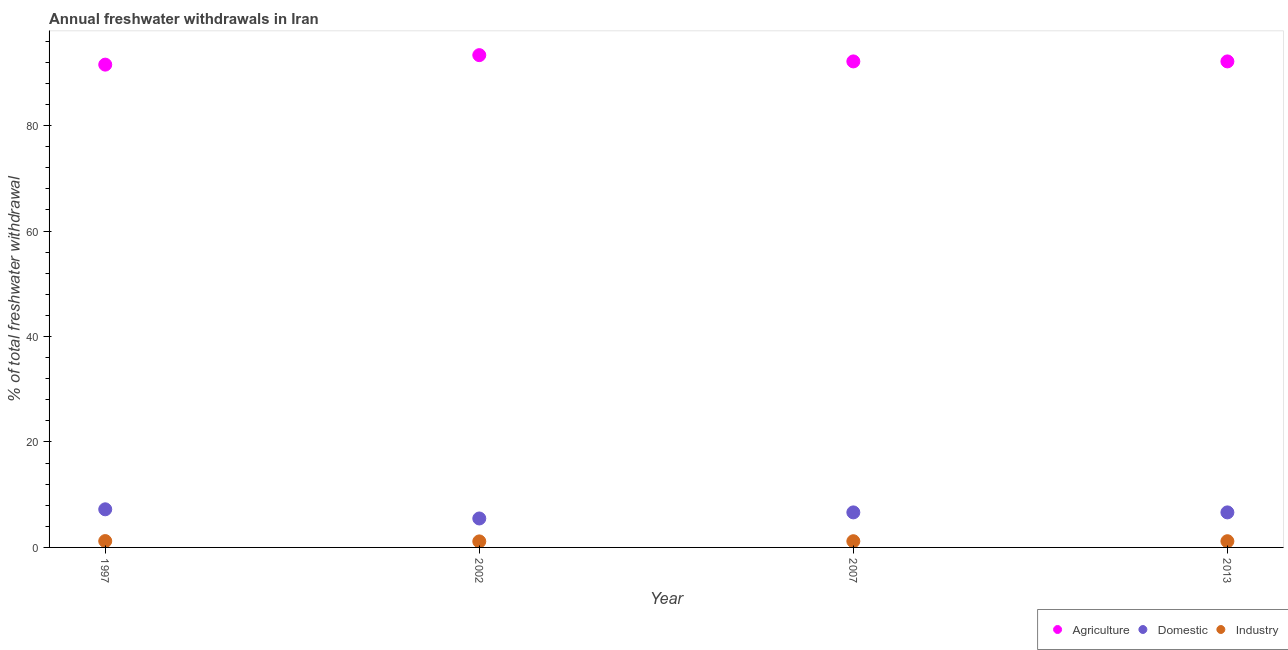Is the number of dotlines equal to the number of legend labels?
Offer a very short reply. Yes. What is the percentage of freshwater withdrawal for agriculture in 2013?
Your response must be concise. 92.18. Across all years, what is the maximum percentage of freshwater withdrawal for agriculture?
Provide a short and direct response. 93.37. Across all years, what is the minimum percentage of freshwater withdrawal for agriculture?
Your answer should be very brief. 91.57. What is the total percentage of freshwater withdrawal for agriculture in the graph?
Your response must be concise. 369.3. What is the difference between the percentage of freshwater withdrawal for industry in 1997 and that in 2013?
Your answer should be very brief. 0.03. What is the difference between the percentage of freshwater withdrawal for agriculture in 2013 and the percentage of freshwater withdrawal for industry in 2002?
Your answer should be very brief. 91.04. What is the average percentage of freshwater withdrawal for industry per year?
Give a very brief answer. 1.18. In the year 2013, what is the difference between the percentage of freshwater withdrawal for agriculture and percentage of freshwater withdrawal for domestic purposes?
Ensure brevity in your answer.  85.54. What is the ratio of the percentage of freshwater withdrawal for agriculture in 2002 to that in 2007?
Provide a succinct answer. 1.01. Is the percentage of freshwater withdrawal for agriculture in 2007 less than that in 2013?
Offer a very short reply. No. What is the difference between the highest and the second highest percentage of freshwater withdrawal for agriculture?
Provide a succinct answer. 1.19. What is the difference between the highest and the lowest percentage of freshwater withdrawal for domestic purposes?
Your answer should be very brief. 1.74. Does the percentage of freshwater withdrawal for agriculture monotonically increase over the years?
Your answer should be very brief. No. Is the percentage of freshwater withdrawal for domestic purposes strictly greater than the percentage of freshwater withdrawal for agriculture over the years?
Your response must be concise. No. Is the percentage of freshwater withdrawal for agriculture strictly less than the percentage of freshwater withdrawal for industry over the years?
Your answer should be compact. No. How many years are there in the graph?
Offer a very short reply. 4. Are the values on the major ticks of Y-axis written in scientific E-notation?
Offer a terse response. No. Does the graph contain any zero values?
Keep it short and to the point. No. How are the legend labels stacked?
Provide a short and direct response. Horizontal. What is the title of the graph?
Provide a succinct answer. Annual freshwater withdrawals in Iran. Does "Domestic" appear as one of the legend labels in the graph?
Offer a terse response. Yes. What is the label or title of the Y-axis?
Provide a succinct answer. % of total freshwater withdrawal. What is the % of total freshwater withdrawal in Agriculture in 1997?
Provide a short and direct response. 91.57. What is the % of total freshwater withdrawal of Domestic in 1997?
Ensure brevity in your answer.  7.23. What is the % of total freshwater withdrawal in Industry in 1997?
Keep it short and to the point. 1.21. What is the % of total freshwater withdrawal of Agriculture in 2002?
Your response must be concise. 93.37. What is the % of total freshwater withdrawal of Domestic in 2002?
Make the answer very short. 5.49. What is the % of total freshwater withdrawal in Industry in 2002?
Provide a succinct answer. 1.14. What is the % of total freshwater withdrawal in Agriculture in 2007?
Your answer should be compact. 92.18. What is the % of total freshwater withdrawal of Domestic in 2007?
Your response must be concise. 6.64. What is the % of total freshwater withdrawal of Industry in 2007?
Provide a succinct answer. 1.18. What is the % of total freshwater withdrawal in Agriculture in 2013?
Give a very brief answer. 92.18. What is the % of total freshwater withdrawal of Domestic in 2013?
Your response must be concise. 6.64. What is the % of total freshwater withdrawal of Industry in 2013?
Provide a short and direct response. 1.18. Across all years, what is the maximum % of total freshwater withdrawal in Agriculture?
Keep it short and to the point. 93.37. Across all years, what is the maximum % of total freshwater withdrawal in Domestic?
Your answer should be very brief. 7.23. Across all years, what is the maximum % of total freshwater withdrawal of Industry?
Your answer should be very brief. 1.21. Across all years, what is the minimum % of total freshwater withdrawal of Agriculture?
Ensure brevity in your answer.  91.57. Across all years, what is the minimum % of total freshwater withdrawal in Domestic?
Give a very brief answer. 5.49. Across all years, what is the minimum % of total freshwater withdrawal of Industry?
Your response must be concise. 1.14. What is the total % of total freshwater withdrawal of Agriculture in the graph?
Ensure brevity in your answer.  369.3. What is the total % of total freshwater withdrawal of Domestic in the graph?
Give a very brief answer. 26.01. What is the total % of total freshwater withdrawal in Industry in the graph?
Provide a succinct answer. 4.71. What is the difference between the % of total freshwater withdrawal of Domestic in 1997 and that in 2002?
Give a very brief answer. 1.74. What is the difference between the % of total freshwater withdrawal in Industry in 1997 and that in 2002?
Make the answer very short. 0.06. What is the difference between the % of total freshwater withdrawal of Agriculture in 1997 and that in 2007?
Provide a short and direct response. -0.61. What is the difference between the % of total freshwater withdrawal in Domestic in 1997 and that in 2007?
Your response must be concise. 0.58. What is the difference between the % of total freshwater withdrawal in Industry in 1997 and that in 2007?
Ensure brevity in your answer.  0.03. What is the difference between the % of total freshwater withdrawal of Agriculture in 1997 and that in 2013?
Provide a short and direct response. -0.61. What is the difference between the % of total freshwater withdrawal in Domestic in 1997 and that in 2013?
Your response must be concise. 0.58. What is the difference between the % of total freshwater withdrawal of Industry in 1997 and that in 2013?
Offer a terse response. 0.03. What is the difference between the % of total freshwater withdrawal of Agriculture in 2002 and that in 2007?
Provide a succinct answer. 1.19. What is the difference between the % of total freshwater withdrawal of Domestic in 2002 and that in 2007?
Offer a very short reply. -1.15. What is the difference between the % of total freshwater withdrawal in Industry in 2002 and that in 2007?
Your response must be concise. -0.04. What is the difference between the % of total freshwater withdrawal in Agriculture in 2002 and that in 2013?
Your answer should be compact. 1.19. What is the difference between the % of total freshwater withdrawal of Domestic in 2002 and that in 2013?
Your response must be concise. -1.15. What is the difference between the % of total freshwater withdrawal of Industry in 2002 and that in 2013?
Offer a terse response. -0.04. What is the difference between the % of total freshwater withdrawal in Agriculture in 2007 and that in 2013?
Ensure brevity in your answer.  0. What is the difference between the % of total freshwater withdrawal of Agriculture in 1997 and the % of total freshwater withdrawal of Domestic in 2002?
Make the answer very short. 86.08. What is the difference between the % of total freshwater withdrawal in Agriculture in 1997 and the % of total freshwater withdrawal in Industry in 2002?
Offer a terse response. 90.43. What is the difference between the % of total freshwater withdrawal of Domestic in 1997 and the % of total freshwater withdrawal of Industry in 2002?
Give a very brief answer. 6.09. What is the difference between the % of total freshwater withdrawal of Agriculture in 1997 and the % of total freshwater withdrawal of Domestic in 2007?
Your answer should be compact. 84.92. What is the difference between the % of total freshwater withdrawal in Agriculture in 1997 and the % of total freshwater withdrawal in Industry in 2007?
Keep it short and to the point. 90.39. What is the difference between the % of total freshwater withdrawal in Domestic in 1997 and the % of total freshwater withdrawal in Industry in 2007?
Your answer should be compact. 6.05. What is the difference between the % of total freshwater withdrawal in Agriculture in 1997 and the % of total freshwater withdrawal in Domestic in 2013?
Ensure brevity in your answer.  84.92. What is the difference between the % of total freshwater withdrawal of Agriculture in 1997 and the % of total freshwater withdrawal of Industry in 2013?
Give a very brief answer. 90.39. What is the difference between the % of total freshwater withdrawal of Domestic in 1997 and the % of total freshwater withdrawal of Industry in 2013?
Ensure brevity in your answer.  6.05. What is the difference between the % of total freshwater withdrawal in Agriculture in 2002 and the % of total freshwater withdrawal in Domestic in 2007?
Your response must be concise. 86.72. What is the difference between the % of total freshwater withdrawal of Agriculture in 2002 and the % of total freshwater withdrawal of Industry in 2007?
Your answer should be very brief. 92.19. What is the difference between the % of total freshwater withdrawal in Domestic in 2002 and the % of total freshwater withdrawal in Industry in 2007?
Give a very brief answer. 4.31. What is the difference between the % of total freshwater withdrawal in Agriculture in 2002 and the % of total freshwater withdrawal in Domestic in 2013?
Ensure brevity in your answer.  86.72. What is the difference between the % of total freshwater withdrawal of Agriculture in 2002 and the % of total freshwater withdrawal of Industry in 2013?
Your answer should be compact. 92.19. What is the difference between the % of total freshwater withdrawal of Domestic in 2002 and the % of total freshwater withdrawal of Industry in 2013?
Keep it short and to the point. 4.31. What is the difference between the % of total freshwater withdrawal in Agriculture in 2007 and the % of total freshwater withdrawal in Domestic in 2013?
Give a very brief answer. 85.53. What is the difference between the % of total freshwater withdrawal in Agriculture in 2007 and the % of total freshwater withdrawal in Industry in 2013?
Provide a short and direct response. 91. What is the difference between the % of total freshwater withdrawal of Domestic in 2007 and the % of total freshwater withdrawal of Industry in 2013?
Ensure brevity in your answer.  5.47. What is the average % of total freshwater withdrawal in Agriculture per year?
Your answer should be very brief. 92.33. What is the average % of total freshwater withdrawal of Domestic per year?
Offer a terse response. 6.5. What is the average % of total freshwater withdrawal in Industry per year?
Your response must be concise. 1.18. In the year 1997, what is the difference between the % of total freshwater withdrawal of Agriculture and % of total freshwater withdrawal of Domestic?
Ensure brevity in your answer.  84.34. In the year 1997, what is the difference between the % of total freshwater withdrawal of Agriculture and % of total freshwater withdrawal of Industry?
Keep it short and to the point. 90.36. In the year 1997, what is the difference between the % of total freshwater withdrawal of Domestic and % of total freshwater withdrawal of Industry?
Offer a terse response. 6.02. In the year 2002, what is the difference between the % of total freshwater withdrawal of Agriculture and % of total freshwater withdrawal of Domestic?
Give a very brief answer. 87.88. In the year 2002, what is the difference between the % of total freshwater withdrawal in Agriculture and % of total freshwater withdrawal in Industry?
Keep it short and to the point. 92.23. In the year 2002, what is the difference between the % of total freshwater withdrawal in Domestic and % of total freshwater withdrawal in Industry?
Provide a succinct answer. 4.35. In the year 2007, what is the difference between the % of total freshwater withdrawal in Agriculture and % of total freshwater withdrawal in Domestic?
Provide a succinct answer. 85.53. In the year 2007, what is the difference between the % of total freshwater withdrawal in Agriculture and % of total freshwater withdrawal in Industry?
Offer a terse response. 91. In the year 2007, what is the difference between the % of total freshwater withdrawal of Domestic and % of total freshwater withdrawal of Industry?
Your response must be concise. 5.47. In the year 2013, what is the difference between the % of total freshwater withdrawal of Agriculture and % of total freshwater withdrawal of Domestic?
Give a very brief answer. 85.53. In the year 2013, what is the difference between the % of total freshwater withdrawal in Agriculture and % of total freshwater withdrawal in Industry?
Your answer should be compact. 91. In the year 2013, what is the difference between the % of total freshwater withdrawal in Domestic and % of total freshwater withdrawal in Industry?
Make the answer very short. 5.47. What is the ratio of the % of total freshwater withdrawal in Agriculture in 1997 to that in 2002?
Provide a short and direct response. 0.98. What is the ratio of the % of total freshwater withdrawal in Domestic in 1997 to that in 2002?
Your answer should be compact. 1.32. What is the ratio of the % of total freshwater withdrawal of Industry in 1997 to that in 2002?
Provide a short and direct response. 1.05. What is the ratio of the % of total freshwater withdrawal in Agriculture in 1997 to that in 2007?
Your answer should be very brief. 0.99. What is the ratio of the % of total freshwater withdrawal in Domestic in 1997 to that in 2007?
Offer a terse response. 1.09. What is the ratio of the % of total freshwater withdrawal of Industry in 1997 to that in 2007?
Ensure brevity in your answer.  1.02. What is the ratio of the % of total freshwater withdrawal in Agriculture in 1997 to that in 2013?
Give a very brief answer. 0.99. What is the ratio of the % of total freshwater withdrawal in Domestic in 1997 to that in 2013?
Provide a succinct answer. 1.09. What is the ratio of the % of total freshwater withdrawal of Industry in 1997 to that in 2013?
Ensure brevity in your answer.  1.02. What is the ratio of the % of total freshwater withdrawal of Agriculture in 2002 to that in 2007?
Make the answer very short. 1.01. What is the ratio of the % of total freshwater withdrawal of Domestic in 2002 to that in 2007?
Provide a succinct answer. 0.83. What is the ratio of the % of total freshwater withdrawal of Industry in 2002 to that in 2007?
Provide a short and direct response. 0.97. What is the ratio of the % of total freshwater withdrawal in Agriculture in 2002 to that in 2013?
Give a very brief answer. 1.01. What is the ratio of the % of total freshwater withdrawal of Domestic in 2002 to that in 2013?
Provide a succinct answer. 0.83. What is the ratio of the % of total freshwater withdrawal in Industry in 2002 to that in 2013?
Give a very brief answer. 0.97. What is the ratio of the % of total freshwater withdrawal in Domestic in 2007 to that in 2013?
Your answer should be compact. 1. What is the ratio of the % of total freshwater withdrawal in Industry in 2007 to that in 2013?
Make the answer very short. 1. What is the difference between the highest and the second highest % of total freshwater withdrawal in Agriculture?
Your answer should be compact. 1.19. What is the difference between the highest and the second highest % of total freshwater withdrawal of Domestic?
Keep it short and to the point. 0.58. What is the difference between the highest and the second highest % of total freshwater withdrawal of Industry?
Your answer should be very brief. 0.03. What is the difference between the highest and the lowest % of total freshwater withdrawal of Domestic?
Ensure brevity in your answer.  1.74. What is the difference between the highest and the lowest % of total freshwater withdrawal in Industry?
Offer a terse response. 0.06. 